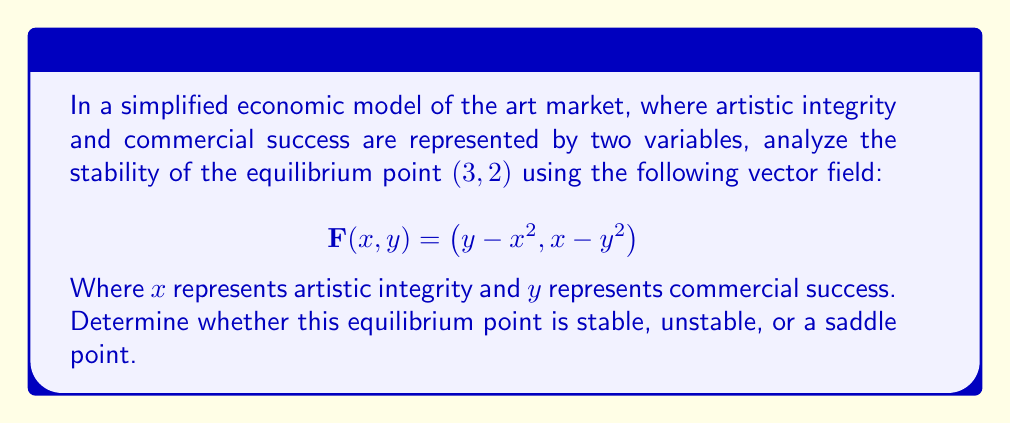Can you answer this question? To analyze the stability of the equilibrium point, we'll follow these steps:

1. Verify that $(3, 2)$ is indeed an equilibrium point:
   $$\mathbf{F}(3, 2) = (2 - 3^2, 3 - 2^2) = (-7, -1) \neq (0, 0)$$
   This point is not an equilibrium point, so we need to find the actual equilibrium point.

2. Find the actual equilibrium point by solving:
   $$y - x^2 = 0 \text{ and } x - y^2 = 0$$
   Substituting $y = x^2$ into the second equation:
   $$x - (x^2)^2 = 0$$
   $$x - x^4 = 0$$
   $$x(1 - x^3) = 0$$
   $$x = 0 \text{ or } x = 1$$
   When $x = 0$, $y = 0$, and when $x = 1$, $y = 1$
   So the equilibrium points are $(0, 0)$ and $(1, 1)$

3. Analyze the stability of $(1, 1)$:
   Calculate the Jacobian matrix at $(1, 1)$:
   $$J = \begin{bmatrix}
   \frac{\partial F_1}{\partial x} & \frac{\partial F_1}{\partial y} \\
   \frac{\partial F_2}{\partial x} & \frac{\partial F_2}{\partial y}
   \end{bmatrix} = \begin{bmatrix}
   -2x & 1 \\
   1 & -2y
   \end{bmatrix}$$

   At $(1, 1)$:
   $$J(1, 1) = \begin{bmatrix}
   -2 & 1 \\
   1 & -2
   \end{bmatrix}$$

4. Find the eigenvalues of $J(1, 1)$:
   $$\det(J - \lambda I) = \begin{vmatrix}
   -2 - \lambda & 1 \\
   1 & -2 - \lambda
   \end{vmatrix} = 0$$
   $$(-2 - \lambda)^2 - 1 = 0$$
   $$\lambda^2 + 4\lambda + 3 = 0$$
   $$(\lambda + 3)(\lambda + 1) = 0$$
   $$\lambda_1 = -3, \lambda_2 = -1$$

5. Interpret the results:
   Both eigenvalues are negative real numbers, which indicates that the equilibrium point $(1, 1)$ is a stable node.
Answer: The equilibrium point $(1, 1)$ is stable. 